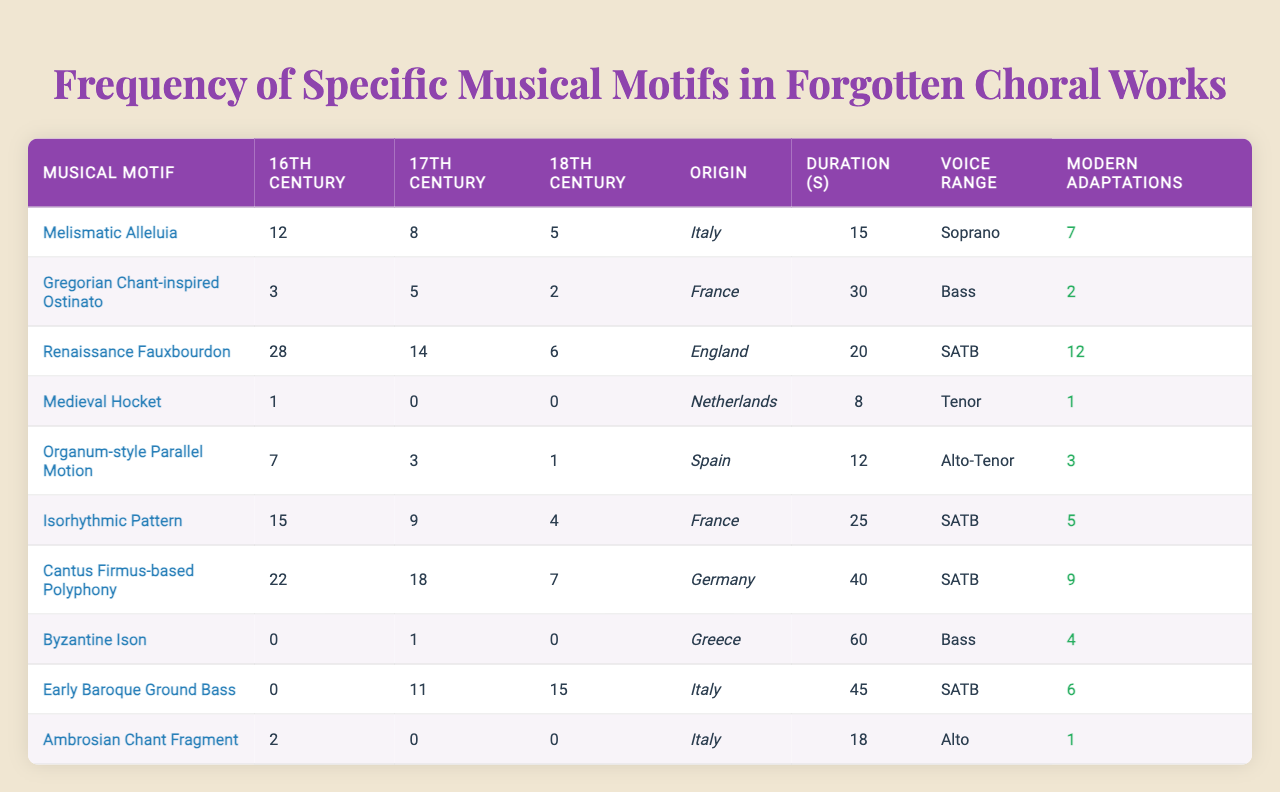What is the highest frequency of a musical motif in the 16th century works? The table shows that the highest frequency of a musical motif in the 16th century works is 28, which corresponds to the "Renaissance Fauxbourdon."
Answer: 28 Which musical motif has the lowest average duration? By looking at the "Average Duration (seconds)" column, "Medieval Hocket" has an average duration of 8 seconds, which is the lowest among all motifs.
Answer: 8 seconds Is there a musical motif from Spain listed in the table? The data contains "Organum-style Parallel Motion," which is associated with Spain, confirming that a motif from Spain is indeed present in the table.
Answer: Yes How many total modern adaptations are there for the "Gregorian Chant-inspired Ostinato"? The table indicates that there are 2 modern adaptations for the "Gregorian Chant-inspired Ostinato."
Answer: 2 Which time period has the highest total frequency of works across all motifs? By adding the counts for each century (16th: 12+3+28+1+7+15+22+0+0+2 = 88, 17th: 8+5+14+0+3+9+18+1+11+0 = 69, 18th: 5+2+6+0+1+4+7+0+15+0 = 40), the 16th century has the highest total at 88.
Answer: 16th century What is the average number of modern adaptations for motifs originating from Italy? The motifs from Italy are "Melismatic Alleluia," "Early Baroque Ground Bass," and "Ambrosian Chant Fragment" with modern adaptations of 7, 3, and 1 respectively. The average is (7 + 3 + 1) / 3 = 11 / 3 = 3.67.
Answer: Approximately 3.67 Is the "Byzantine Ison" the only motif from Greece? The table lists "Byzantine Ison" as the only musical motif with Greece as its geographic origin and does not show any other motifs associated with Greece.
Answer: Yes Which musical motif has the greatest representation in the 18th century? Upon reviewing the table, "Early Baroque Ground Bass" has the greatest representation in the 18th century with a frequency of 15 works.
Answer: Early Baroque Ground Bass How many motifs have more than 10 adaptations in total? By examining the "Modern Adaptations Count," the motifs "Renaissance Fauxbourdon," "Cantus Firmus-based Polyphony," and "Early Baroque Ground Bass" have 12, 9, and 6 adaptations respectively, summing to a total of 3 motifs with over 10 adaptations.
Answer: 3 What is the typical voice range for "Isorhythmic Pattern"? The typical voice range for the "Isorhythmic Pattern" is "SATB" according to the table.
Answer: SATB 